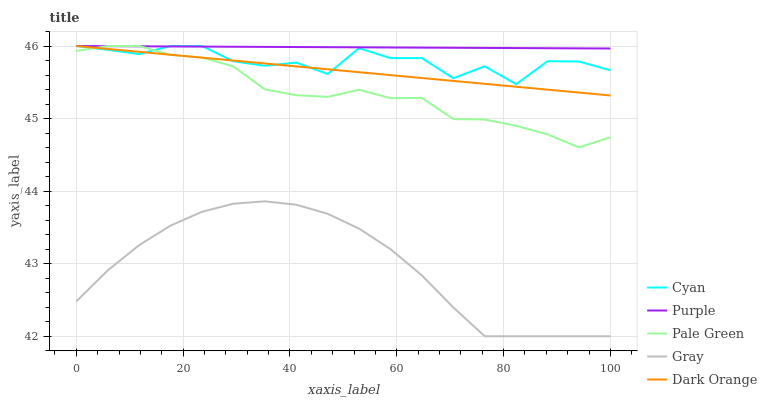Does Gray have the minimum area under the curve?
Answer yes or no. Yes. Does Purple have the maximum area under the curve?
Answer yes or no. Yes. Does Cyan have the minimum area under the curve?
Answer yes or no. No. Does Cyan have the maximum area under the curve?
Answer yes or no. No. Is Dark Orange the smoothest?
Answer yes or no. Yes. Is Cyan the roughest?
Answer yes or no. Yes. Is Pale Green the smoothest?
Answer yes or no. No. Is Pale Green the roughest?
Answer yes or no. No. Does Gray have the lowest value?
Answer yes or no. Yes. Does Cyan have the lowest value?
Answer yes or no. No. Does Dark Orange have the highest value?
Answer yes or no. Yes. Does Gray have the highest value?
Answer yes or no. No. Is Gray less than Pale Green?
Answer yes or no. Yes. Is Pale Green greater than Gray?
Answer yes or no. Yes. Does Dark Orange intersect Cyan?
Answer yes or no. Yes. Is Dark Orange less than Cyan?
Answer yes or no. No. Is Dark Orange greater than Cyan?
Answer yes or no. No. Does Gray intersect Pale Green?
Answer yes or no. No. 